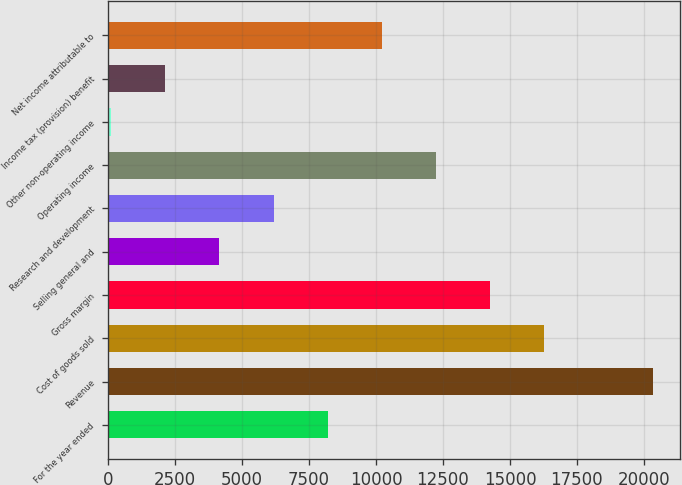Convert chart to OTSL. <chart><loc_0><loc_0><loc_500><loc_500><bar_chart><fcel>For the year ended<fcel>Revenue<fcel>Cost of goods sold<fcel>Gross margin<fcel>Selling general and<fcel>Research and development<fcel>Operating income<fcel>Other non-operating income<fcel>Income tax (provision) benefit<fcel>Net income attributable to<nl><fcel>8196<fcel>20322<fcel>16280<fcel>14259<fcel>4154<fcel>6175<fcel>12238<fcel>112<fcel>2133<fcel>10217<nl></chart> 